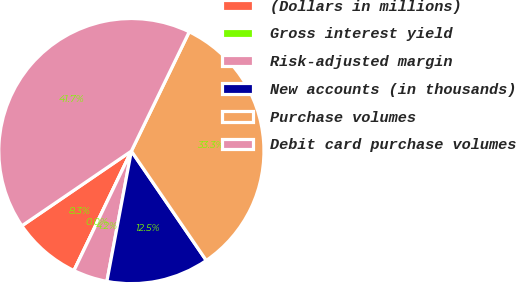Convert chart. <chart><loc_0><loc_0><loc_500><loc_500><pie_chart><fcel>(Dollars in millions)<fcel>Gross interest yield<fcel>Risk-adjusted margin<fcel>New accounts (in thousands)<fcel>Purchase volumes<fcel>Debit card purchase volumes<nl><fcel>8.34%<fcel>0.0%<fcel>4.17%<fcel>12.51%<fcel>33.25%<fcel>41.71%<nl></chart> 